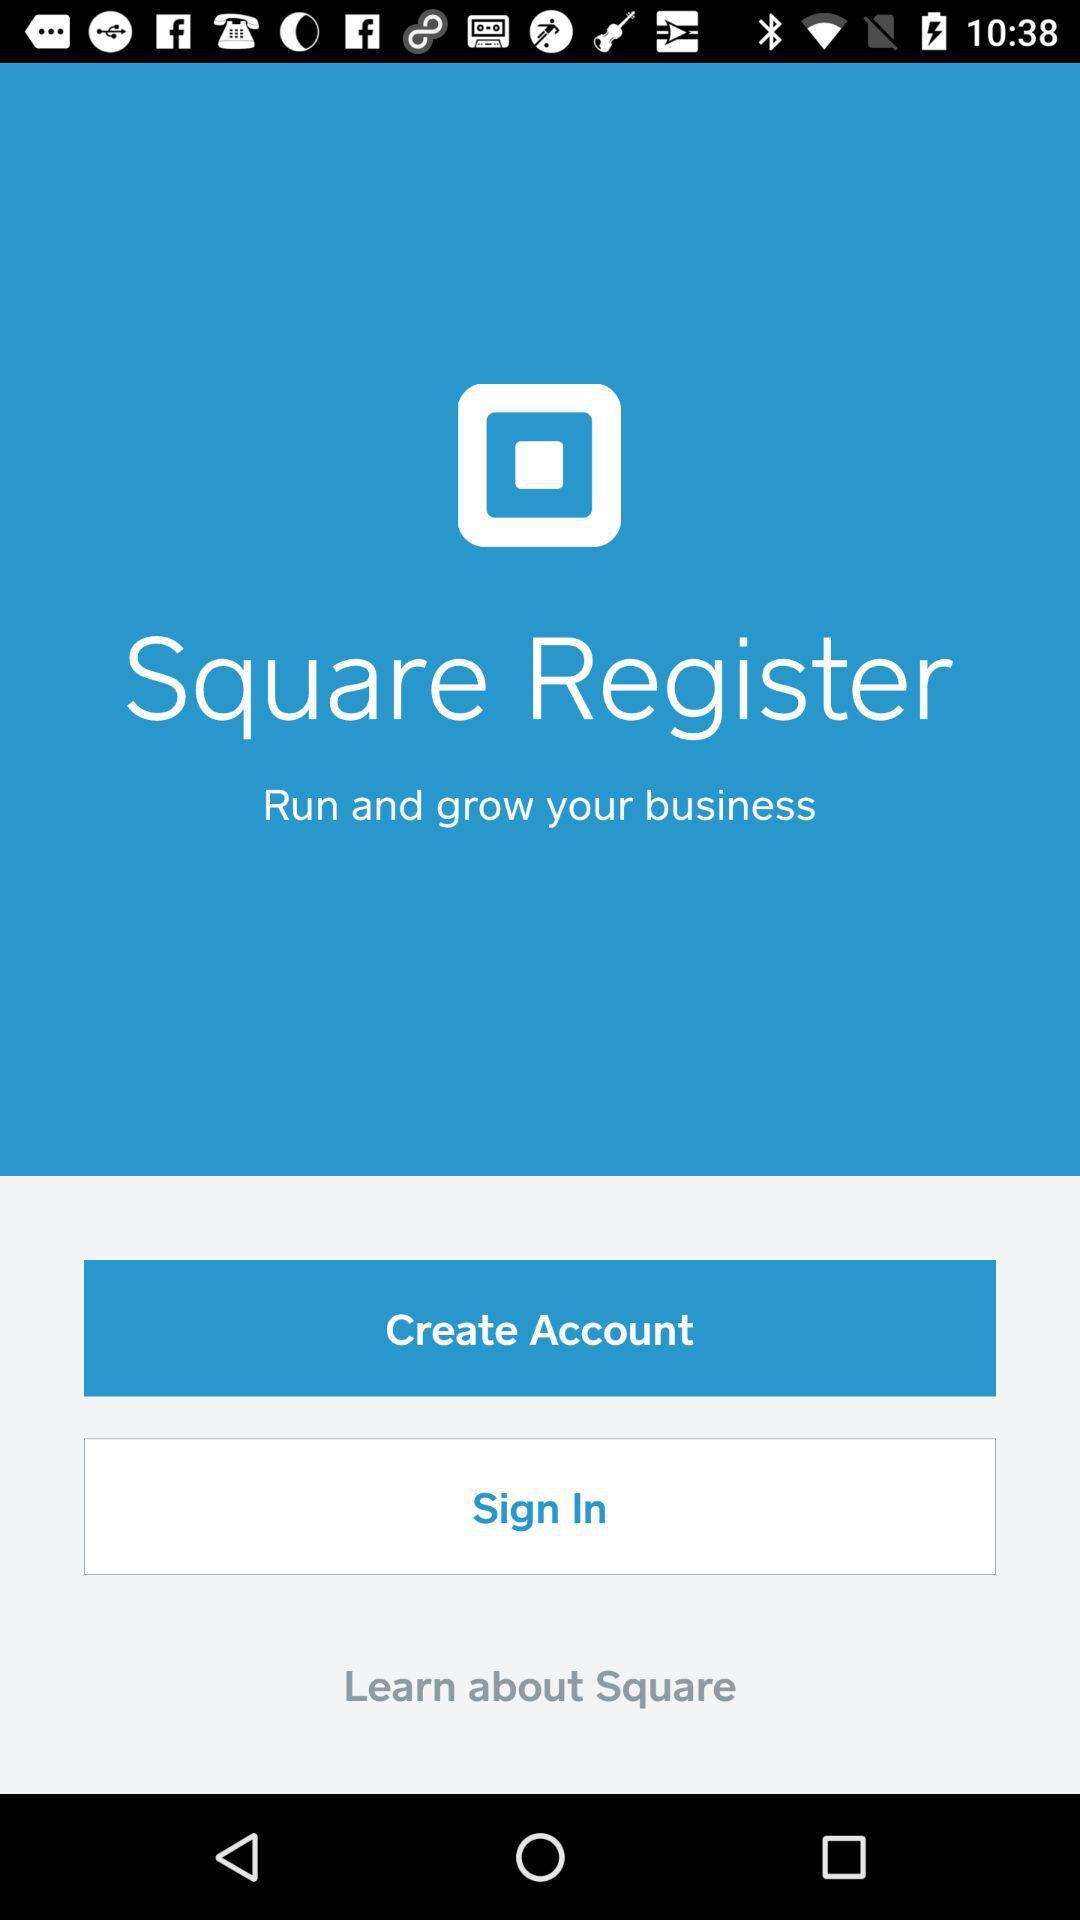When was "Square" founded?
When the provided information is insufficient, respond with <no answer>. <no answer> 